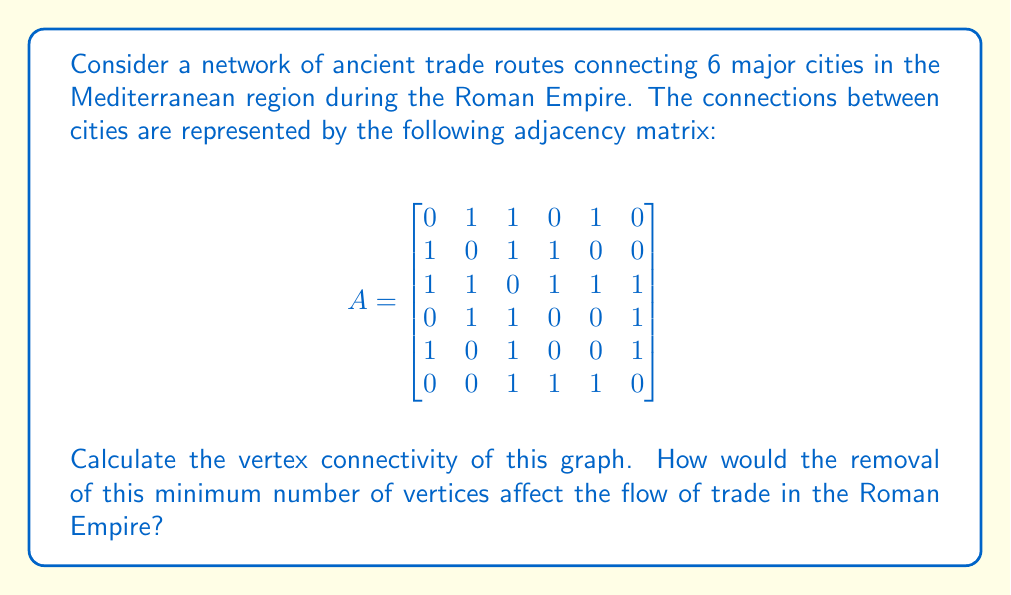Can you solve this math problem? To solve this problem, we'll use graph theory concepts to analyze the connectivity of the historical trade routes:

1. Vertex connectivity is defined as the minimum number of vertices that need to be removed to disconnect the graph.

2. We can determine this by finding the minimum degree of the graph or by analyzing all possible vertex cuts.

3. Let's first calculate the degree of each vertex:
   Vertex 1: 3
   Vertex 2: 3
   Vertex 3: 5
   Vertex 4: 3
   Vertex 5: 3
   Vertex 6: 3

   The minimum degree is 3.

4. Now, let's check if removing any two vertices can disconnect the graph:
   - Removing vertices 1 and 2 doesn't disconnect the graph.
   - Removing vertices 1 and 4 doesn't disconnect the graph.
   - Removing vertices 1 and 6 doesn't disconnect the graph.
   - Removing vertices 2 and 4 doesn't disconnect the graph.
   - Removing vertices 2 and 5 doesn't disconnect the graph.
   - Removing vertices 4 and 5 disconnects the graph.

5. Therefore, the vertex connectivity of this graph is 2.

Historical interpretation:
The vertex connectivity of 2 implies that the Roman trade network was relatively robust. It would take the disruption of at least two major cities to significantly impair the overall trade network. This reflects the Romans' strategic approach to establishing and maintaining trade routes, ensuring multiple pathways for goods to flow between cities.

The removal of these two critical cities (represented by vertices 4 and 5 in our analysis) would have had a substantial impact on the Roman economy. It would have divided the trade network into two separate components, limiting the flow of goods and potentially causing economic strain in certain regions of the empire. This underscores the importance of these key cities as trade hubs and their role in maintaining the cohesion of the Roman economic system.
Answer: The vertex connectivity of the graph is 2. 